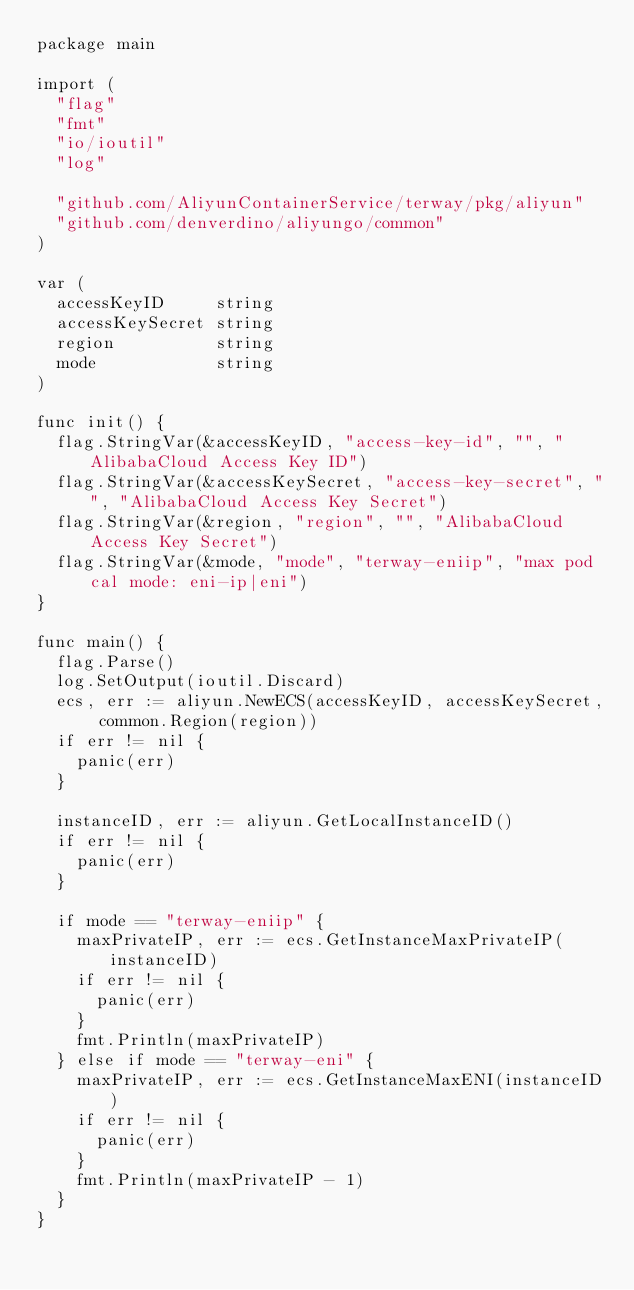Convert code to text. <code><loc_0><loc_0><loc_500><loc_500><_Go_>package main

import (
	"flag"
	"fmt"
	"io/ioutil"
	"log"

	"github.com/AliyunContainerService/terway/pkg/aliyun"
	"github.com/denverdino/aliyungo/common"
)

var (
	accessKeyID     string
	accessKeySecret string
	region          string
	mode            string
)

func init() {
	flag.StringVar(&accessKeyID, "access-key-id", "", "AlibabaCloud Access Key ID")
	flag.StringVar(&accessKeySecret, "access-key-secret", "", "AlibabaCloud Access Key Secret")
	flag.StringVar(&region, "region", "", "AlibabaCloud Access Key Secret")
	flag.StringVar(&mode, "mode", "terway-eniip", "max pod cal mode: eni-ip|eni")
}

func main() {
	flag.Parse()
	log.SetOutput(ioutil.Discard)
	ecs, err := aliyun.NewECS(accessKeyID, accessKeySecret, common.Region(region))
	if err != nil {
		panic(err)
	}

	instanceID, err := aliyun.GetLocalInstanceID()
	if err != nil {
		panic(err)
	}

	if mode == "terway-eniip" {
		maxPrivateIP, err := ecs.GetInstanceMaxPrivateIP(instanceID)
		if err != nil {
			panic(err)
		}
		fmt.Println(maxPrivateIP)
	} else if mode == "terway-eni" {
		maxPrivateIP, err := ecs.GetInstanceMaxENI(instanceID)
		if err != nil {
			panic(err)
		}
		fmt.Println(maxPrivateIP - 1)
	}
}
</code> 